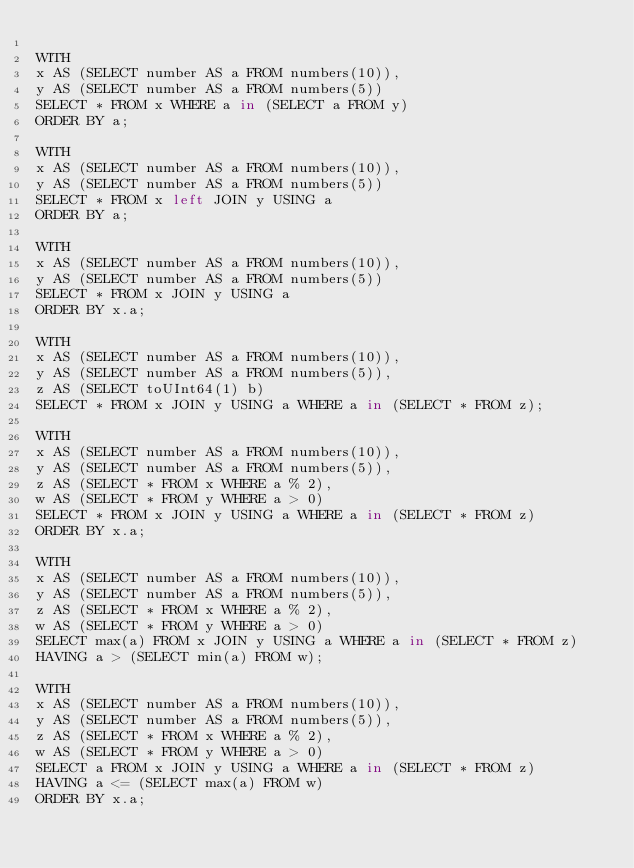<code> <loc_0><loc_0><loc_500><loc_500><_SQL_>
WITH 
x AS (SELECT number AS a FROM numbers(10)),
y AS (SELECT number AS a FROM numbers(5))
SELECT * FROM x WHERE a in (SELECT a FROM y)
ORDER BY a;

WITH 
x AS (SELECT number AS a FROM numbers(10)),
y AS (SELECT number AS a FROM numbers(5))
SELECT * FROM x left JOIN y USING a
ORDER BY a;

WITH 
x AS (SELECT number AS a FROM numbers(10)),
y AS (SELECT number AS a FROM numbers(5))
SELECT * FROM x JOIN y USING a
ORDER BY x.a;

WITH 
x AS (SELECT number AS a FROM numbers(10)),
y AS (SELECT number AS a FROM numbers(5)),
z AS (SELECT toUInt64(1) b)
SELECT * FROM x JOIN y USING a WHERE a in (SELECT * FROM z);

WITH 
x AS (SELECT number AS a FROM numbers(10)),
y AS (SELECT number AS a FROM numbers(5)),
z AS (SELECT * FROM x WHERE a % 2),
w AS (SELECT * FROM y WHERE a > 0)
SELECT * FROM x JOIN y USING a WHERE a in (SELECT * FROM z)
ORDER BY x.a;

WITH 
x AS (SELECT number AS a FROM numbers(10)),
y AS (SELECT number AS a FROM numbers(5)),
z AS (SELECT * FROM x WHERE a % 2),
w AS (SELECT * FROM y WHERE a > 0)
SELECT max(a) FROM x JOIN y USING a WHERE a in (SELECT * FROM z)
HAVING a > (SELECT min(a) FROM w);

WITH 
x AS (SELECT number AS a FROM numbers(10)),
y AS (SELECT number AS a FROM numbers(5)),
z AS (SELECT * FROM x WHERE a % 2),
w AS (SELECT * FROM y WHERE a > 0)
SELECT a FROM x JOIN y USING a WHERE a in (SELECT * FROM z)
HAVING a <= (SELECT max(a) FROM w)
ORDER BY x.a;
</code> 